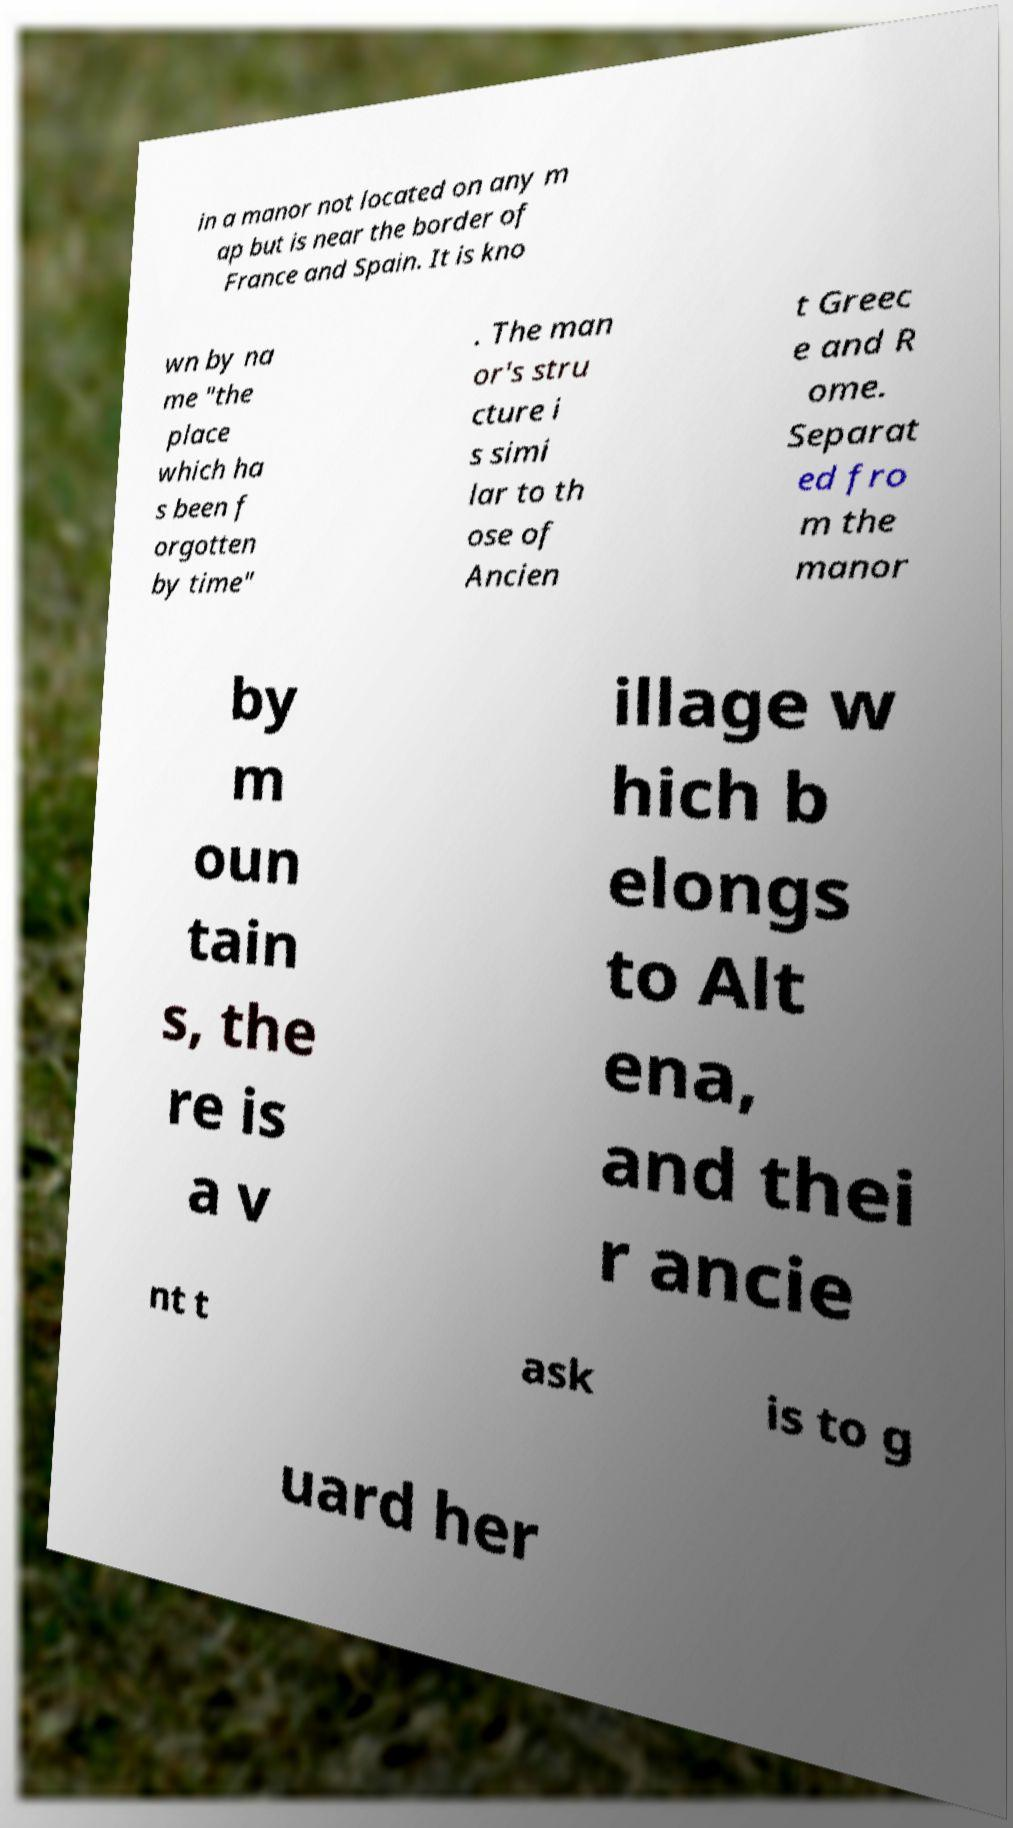Can you accurately transcribe the text from the provided image for me? in a manor not located on any m ap but is near the border of France and Spain. It is kno wn by na me "the place which ha s been f orgotten by time" . The man or's stru cture i s simi lar to th ose of Ancien t Greec e and R ome. Separat ed fro m the manor by m oun tain s, the re is a v illage w hich b elongs to Alt ena, and thei r ancie nt t ask is to g uard her 